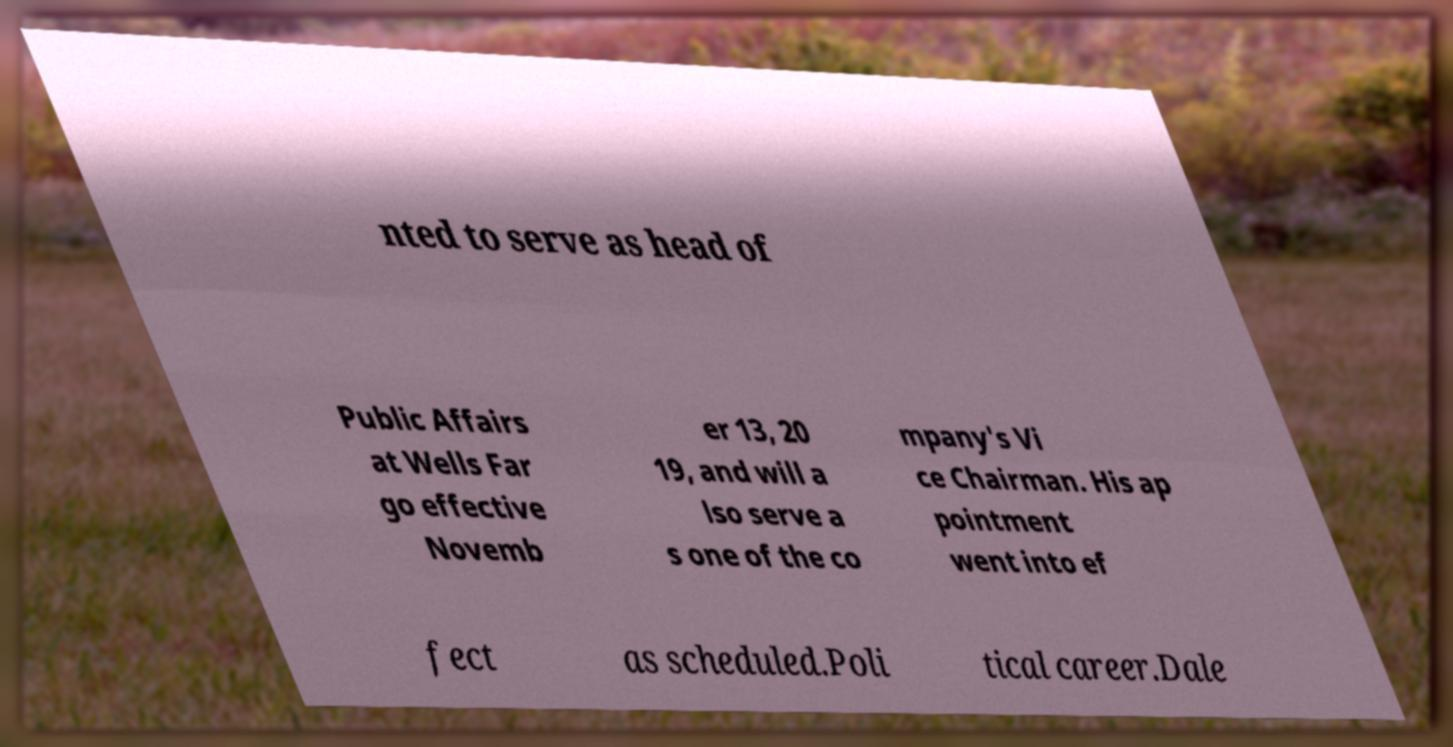I need the written content from this picture converted into text. Can you do that? nted to serve as head of Public Affairs at Wells Far go effective Novemb er 13, 20 19, and will a lso serve a s one of the co mpany's Vi ce Chairman. His ap pointment went into ef fect as scheduled.Poli tical career.Dale 